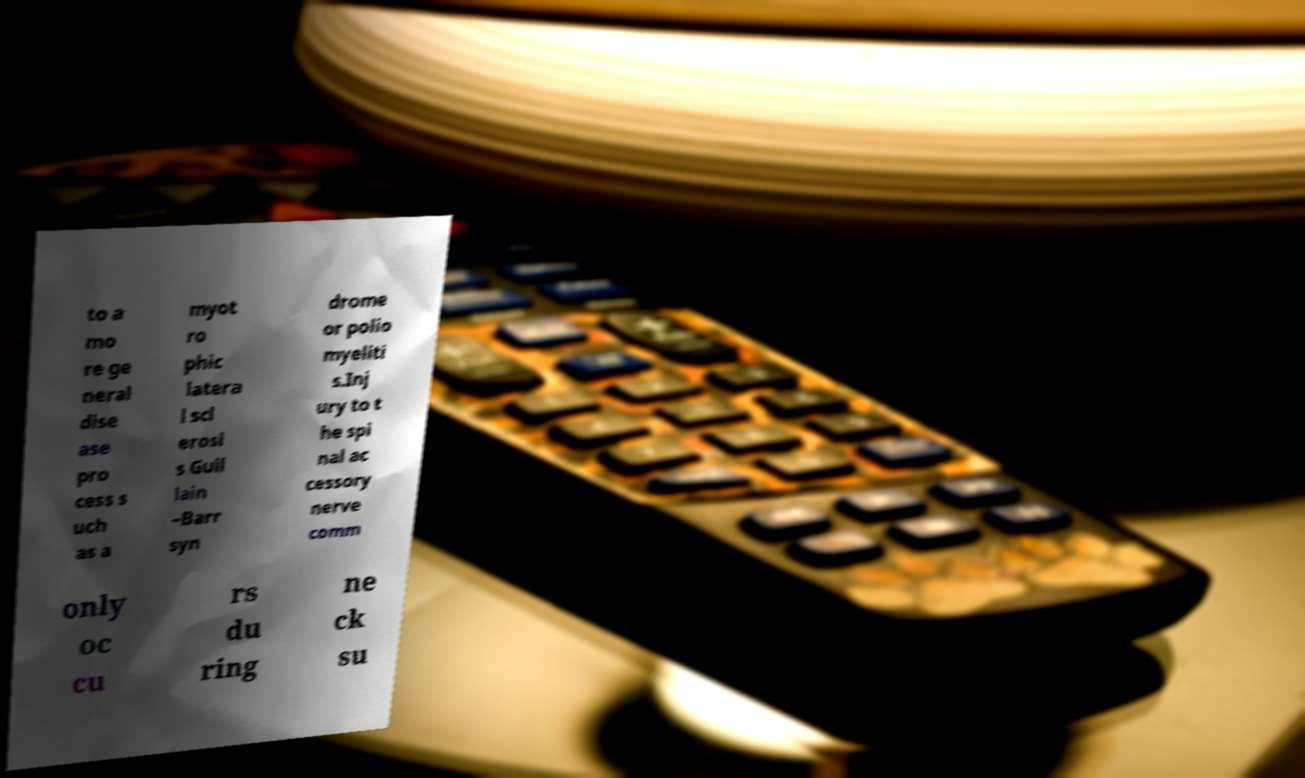Please read and relay the text visible in this image. What does it say? to a mo re ge neral dise ase pro cess s uch as a myot ro phic latera l scl erosi s Guil lain –Barr syn drome or polio myeliti s.Inj ury to t he spi nal ac cessory nerve comm only oc cu rs du ring ne ck su 